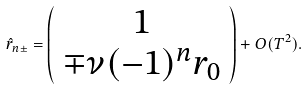<formula> <loc_0><loc_0><loc_500><loc_500>\hat { r } _ { n \pm } = \left ( \begin{array} { c } 1 \\ \mp \nu ( - 1 ) ^ { n } r _ { 0 } \end{array} \right ) + O ( T ^ { 2 } ) .</formula> 